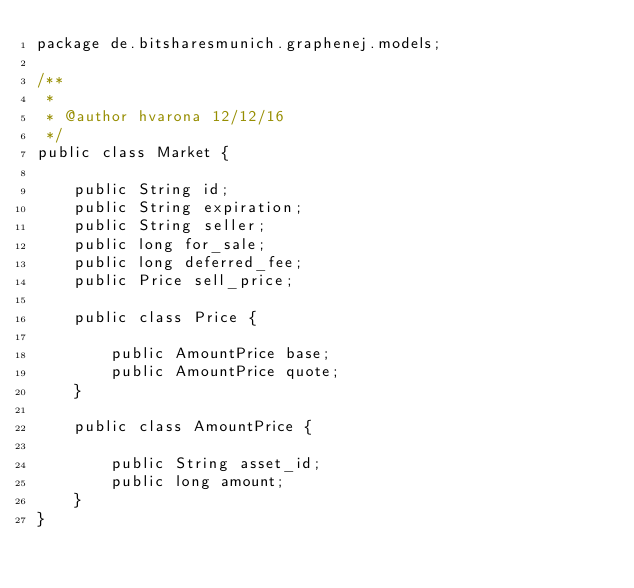Convert code to text. <code><loc_0><loc_0><loc_500><loc_500><_Java_>package de.bitsharesmunich.graphenej.models;

/**
 *
 * @author hvarona 12/12/16
 */
public class Market {

    public String id;
    public String expiration;
    public String seller;
    public long for_sale;
    public long deferred_fee;
    public Price sell_price;

    public class Price {

        public AmountPrice base;
        public AmountPrice quote;
    }

    public class AmountPrice {

        public String asset_id;
        public long amount;
    }
}</code> 